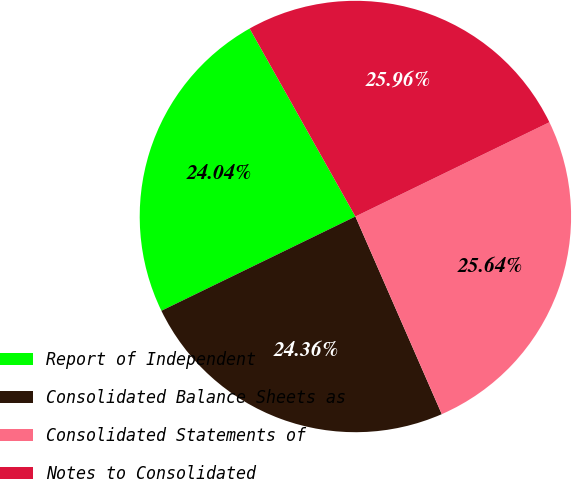Convert chart to OTSL. <chart><loc_0><loc_0><loc_500><loc_500><pie_chart><fcel>Report of Independent<fcel>Consolidated Balance Sheets as<fcel>Consolidated Statements of<fcel>Notes to Consolidated<nl><fcel>24.04%<fcel>24.36%<fcel>25.64%<fcel>25.96%<nl></chart> 